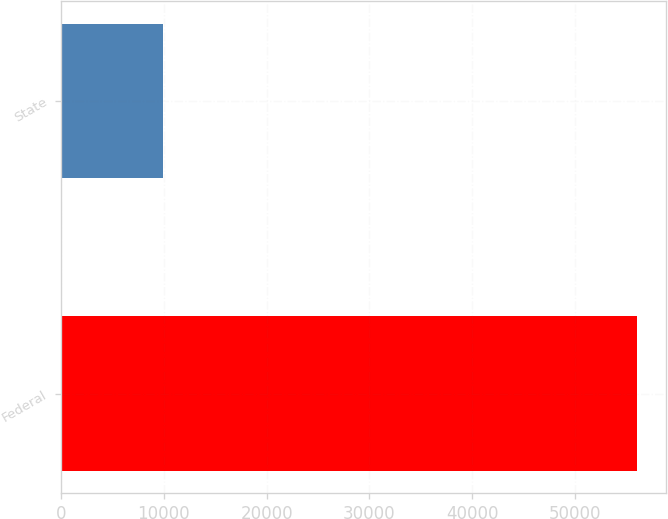Convert chart to OTSL. <chart><loc_0><loc_0><loc_500><loc_500><bar_chart><fcel>Federal<fcel>State<nl><fcel>56060<fcel>9948<nl></chart> 